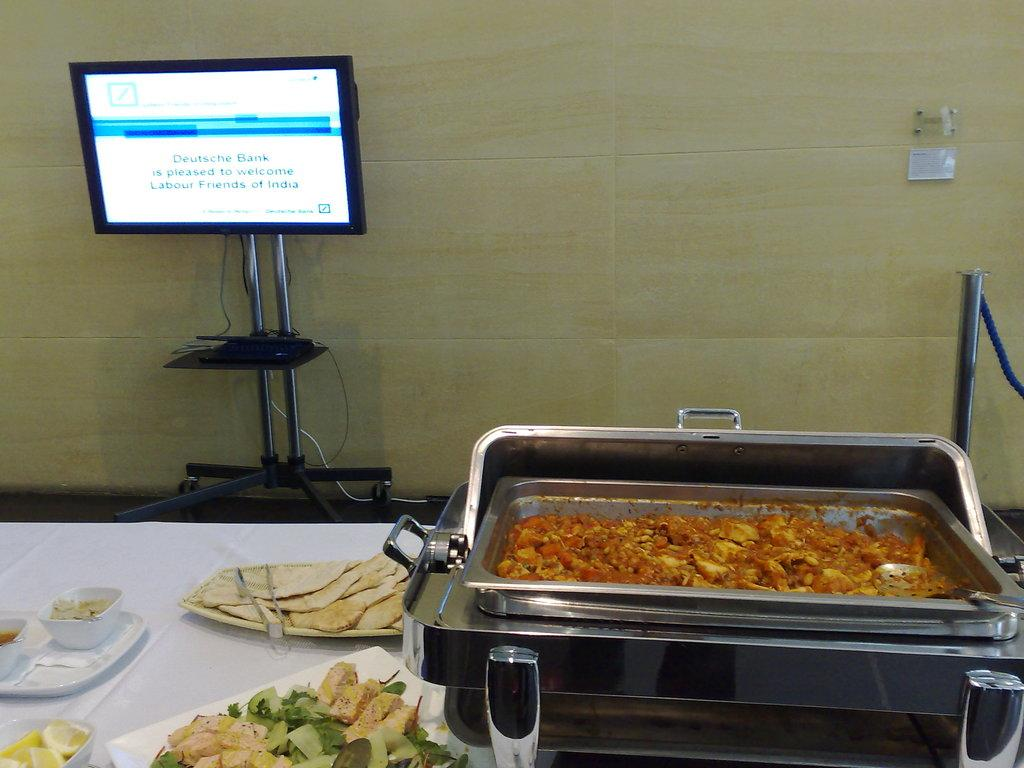Provide a one-sentence caption for the provided image. A table of food and a computer screen with a message from Deutsche Bank welcoming the Labour Friends of India. 